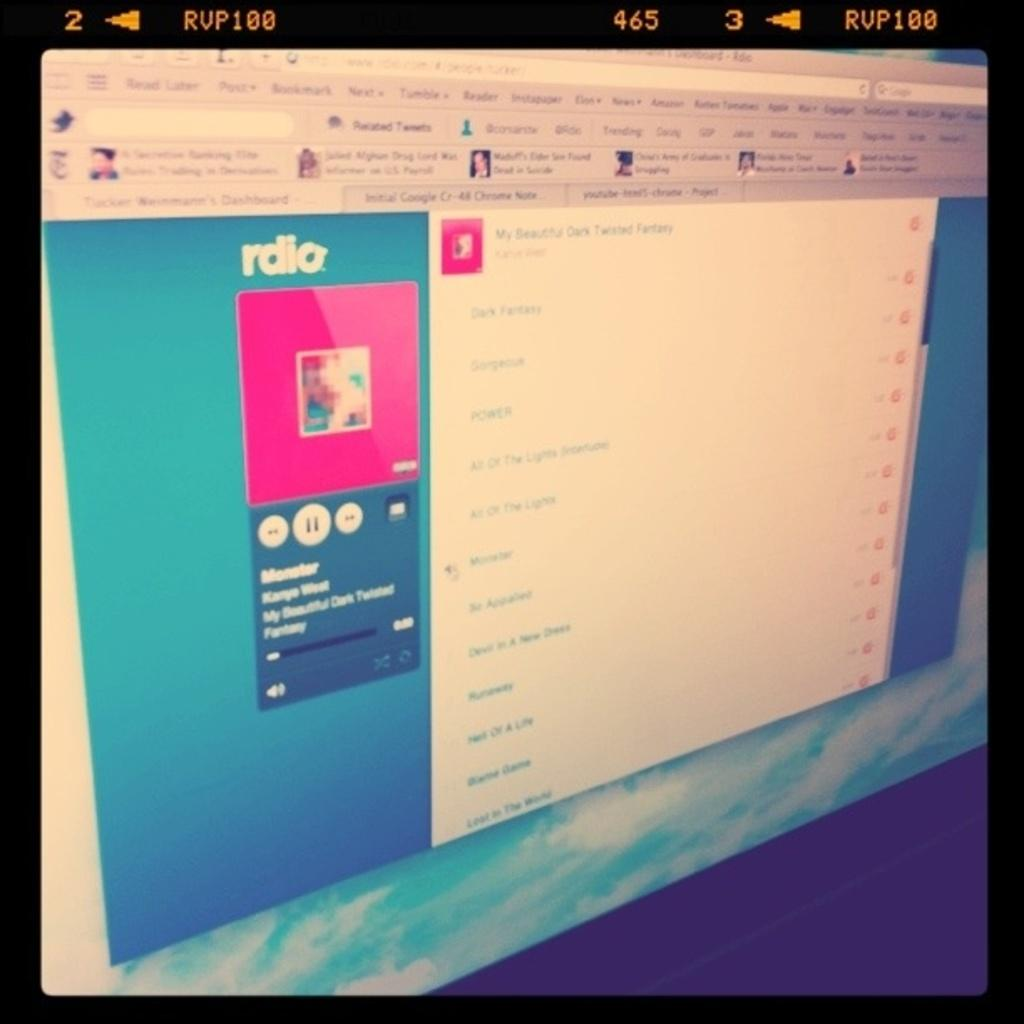<image>
Present a compact description of the photo's key features. A page is opened on the display that is titled "My beautiful dark twisted fantasy". 